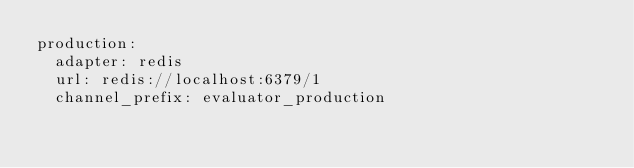<code> <loc_0><loc_0><loc_500><loc_500><_YAML_>production:
  adapter: redis
  url: redis://localhost:6379/1
  channel_prefix: evaluator_production
</code> 